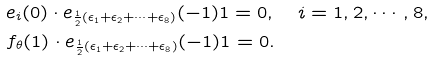<formula> <loc_0><loc_0><loc_500><loc_500>& e _ { i } ( 0 ) \cdot e _ { \frac { 1 } { 2 } ( \epsilon _ { 1 } + \epsilon _ { 2 } + \cdots + \epsilon _ { 8 } ) } ( - 1 ) 1 = 0 , \quad i = 1 , 2 , \cdots , 8 , \\ & f _ { \theta } ( 1 ) \cdot e _ { \frac { 1 } { 2 } ( \epsilon _ { 1 } + \epsilon _ { 2 } + \cdots + \epsilon _ { 8 } ) } ( - 1 ) 1 = 0 .</formula> 